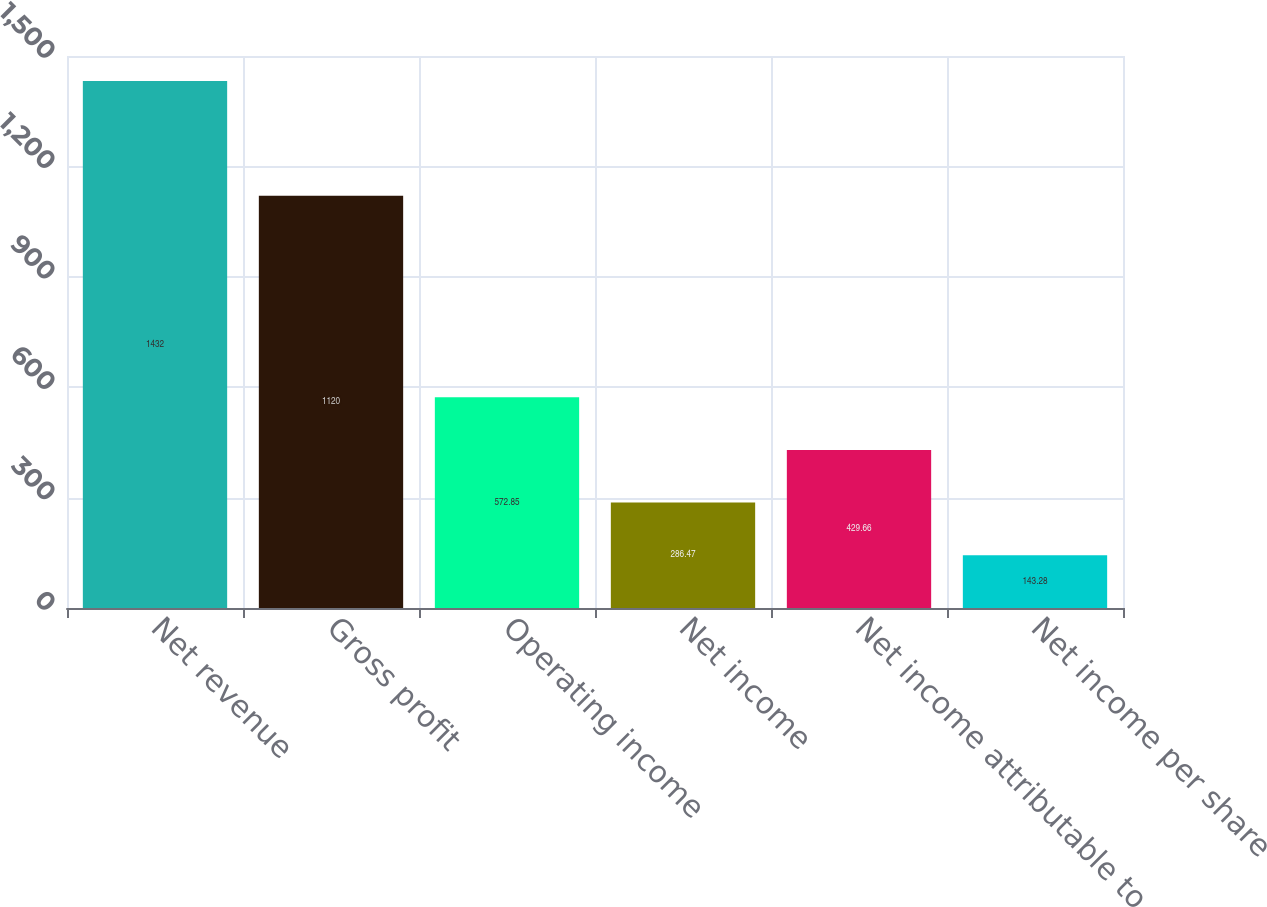<chart> <loc_0><loc_0><loc_500><loc_500><bar_chart><fcel>Net revenue<fcel>Gross profit<fcel>Operating income<fcel>Net income<fcel>Net income attributable to<fcel>Net income per share<nl><fcel>1432<fcel>1120<fcel>572.85<fcel>286.47<fcel>429.66<fcel>143.28<nl></chart> 